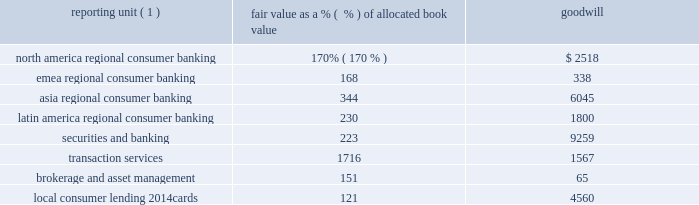The table shows reporting units with goodwill balances as of december 31 , 2010 , and the excess of fair value as a percentage over allocated book value as of the annual impairment test .
In millions of dollars reporting unit ( 1 ) fair value as a % (  % ) of allocated book value goodwill .
( 1 ) local consumer lending 2014other is excluded from the table as there is no goodwill allocated to it .
While no impairment was noted in step one of citigroup 2019s local consumer lending 2014cards reporting unit impairment test at july 1 , 2010 , goodwill present in the reporting unit may be sensitive to further deterioration as the valuation of the reporting unit is particularly dependent upon economic conditions that affect consumer credit risk and behavior .
Citigroup engaged the services of an independent valuation specialist to assist in the valuation of the reporting unit at july 1 , 2010 , using a combination of the market approach and income approach consistent with the valuation model used in past practice , which considered the impact of the penalty fee provisions associated with the credit card accountability responsibility and disclosure act of 2009 ( card act ) that were implemented during 2010 .
Under the market approach for valuing this reporting unit , the key assumption is the selected price multiple .
The selection of the multiple considers the operating performance and financial condition of the local consumer lending 2014cards operations as compared with those of a group of selected publicly traded guideline companies and a group of selected acquired companies .
Among other factors , the level and expected growth in return on tangible equity relative to those of the guideline companies and guideline transactions is considered .
Since the guideline company prices used are on a minority interest basis , the selection of the multiple considers the guideline acquisition prices , which reflect control rights and privileges , in arriving at a multiple that reflects an appropriate control premium .
For the local consumer lending 2014cards valuation under the income approach , the assumptions used as the basis for the model include cash flows for the forecasted period , the assumptions embedded in arriving at an estimation of the terminal value and the discount rate .
The cash flows for the forecasted period are estimated based on management 2019s most recent projections available as of the testing date , giving consideration to targeted equity capital requirements based on selected public guideline companies for the reporting unit .
In arriving at the terminal value for local consumer lending 2014cards , using 2013 as the terminal year , the assumptions used include a long-term growth rate and a price-to-tangible book multiple based on selected public guideline companies for the reporting unit .
The discount rate is based on the reporting unit 2019s estimated cost of equity capital computed under the capital asset pricing model .
Embedded in the key assumptions underlying the valuation model , described above , is the inherent uncertainty regarding the possibility that economic conditions may deteriorate or other events will occur that will impact the business model for local consumer lending 2014cards .
While there is inherent uncertainty embedded in the assumptions used in developing management 2019s forecasts , the company utilized a discount rate at july 1 , 2010 that it believes reflects the risk characteristics and uncertainty specific to management 2019s forecasts and assumptions for the local consumer lending 2014cards reporting unit .
Two primary categories of events exist 2014economic conditions in the u.s .
And regulatory actions 2014which , if they were to occur , could negatively affect key assumptions used in the valuation of local consumer lending 2014cards .
Small deterioration in the assumptions used in the valuations , in particular the discount-rate and growth-rate assumptions used in the net income projections , could significantly affect citigroup 2019s impairment evaluation and , hence , results .
If the future were to differ adversely from management 2019s best estimate of key economic assumptions , and associated cash flows were to decrease by a small margin , citi could potentially experience future material impairment charges with respect to $ 4560 million of goodwill remaining in the local consumer lending 2014 cards reporting unit .
Any such charges , by themselves , would not negatively affect citi 2019s tier 1 and total capital regulatory ratios , tier 1 common ratio , its tangible common equity or citi 2019s liquidity position. .
What is the ratio of the goodwill for north america regional consumer banking to emea regional consumer banking? 
Rationale: the goodwill for north america regional consumer banking was 7.5 times that of emea regional consumer banking
Computations: (2518 / 338)
Answer: 7.4497. 